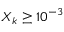Convert formula to latex. <formula><loc_0><loc_0><loc_500><loc_500>X _ { k } \geq 1 0 ^ { - 3 }</formula> 